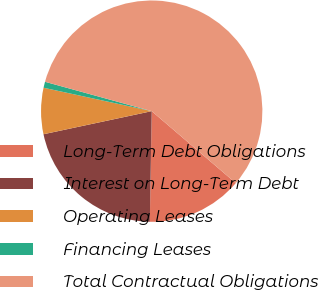Convert chart. <chart><loc_0><loc_0><loc_500><loc_500><pie_chart><fcel>Long-Term Debt Obligations<fcel>Interest on Long-Term Debt<fcel>Operating Leases<fcel>Financing Leases<fcel>Total Contractual Obligations<nl><fcel>14.01%<fcel>21.38%<fcel>6.74%<fcel>0.88%<fcel>56.99%<nl></chart> 